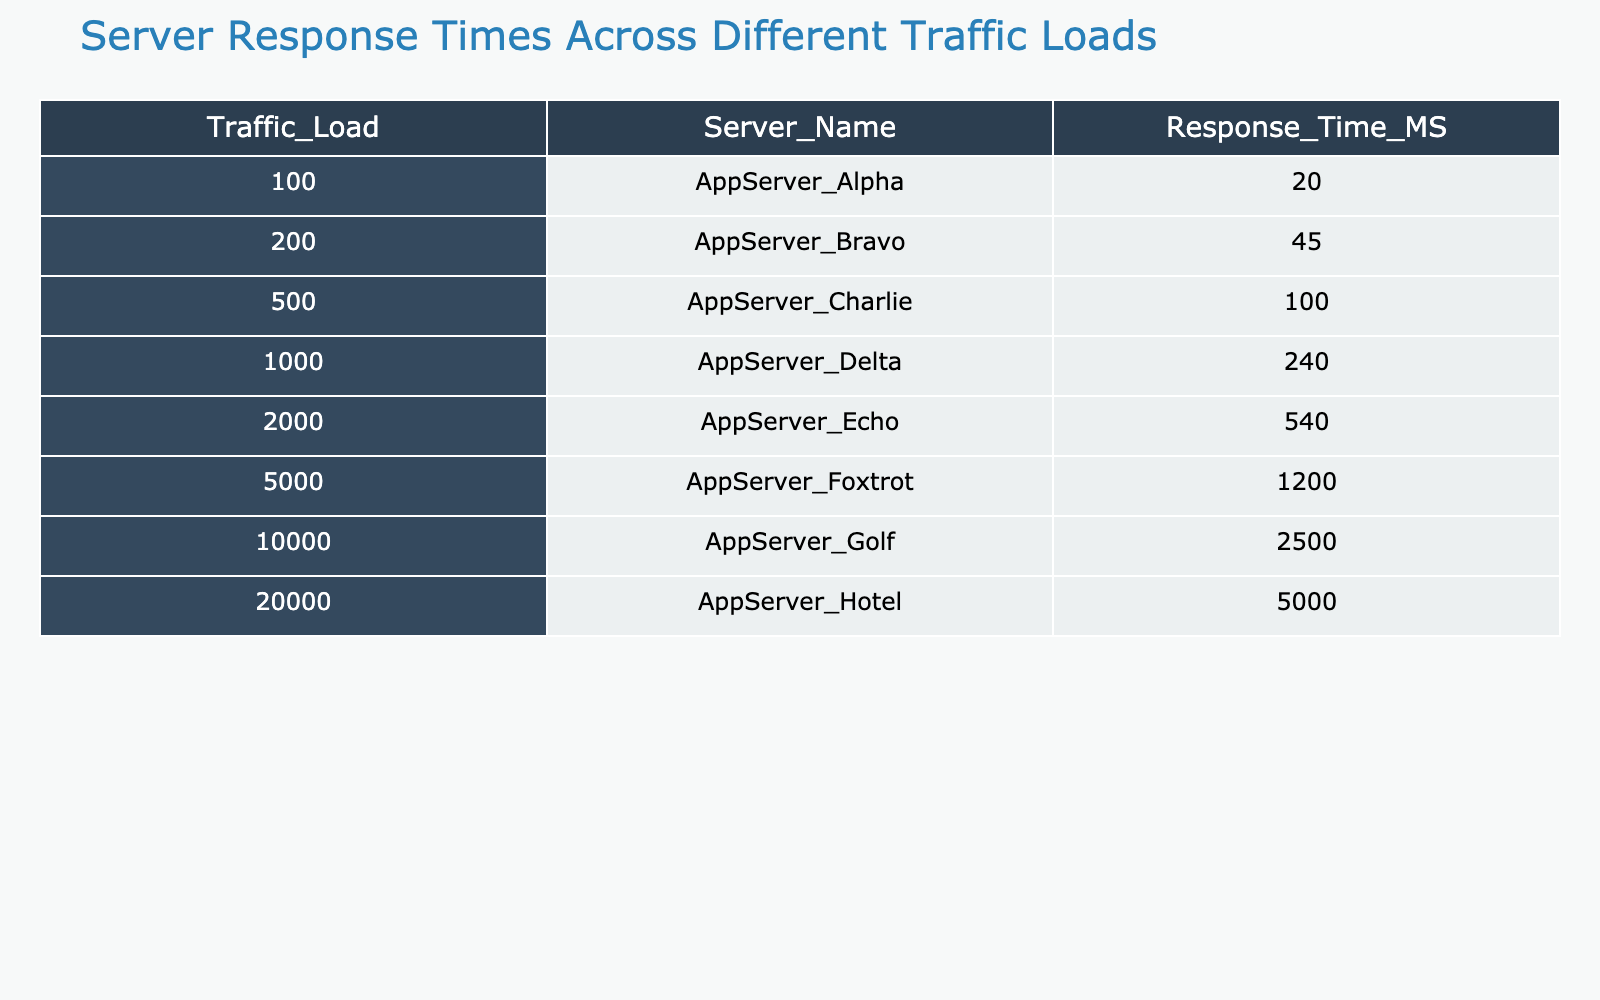What is the response time of AppServer_Delta? The table shows that for the traffic load of 1000, the response time of AppServer_Delta is 240 milliseconds.
Answer: 240 milliseconds Which server has the fastest response time? Looking at the table, AppServer_Alpha has the lowest response time of 20 milliseconds at a traffic load of 100.
Answer: AppServer_Alpha What is the average response time across all servers? To find the average, sum the response times: 20 + 45 + 100 + 240 + 540 + 1200 + 2500 + 5000 = 10245. Then divide by the number of servers (8): 10245 / 8 = 1280.625.
Answer: 1280.625 milliseconds Is the response time of AppServer_Echo less than 600 milliseconds? The response time for AppServer_Echo is 540 milliseconds, which is indeed less than 600 milliseconds.
Answer: Yes What is the difference in response time between AppServer_Foxtrot and AppServer_Golf? AppServer_Foxtrot has a response time of 1200 milliseconds, while AppServer_Golf has 2500 milliseconds. The difference is calculated as 2500 - 1200 = 1300 milliseconds.
Answer: 1300 milliseconds How many servers have a response time greater than 500 milliseconds? By examining the table, AppServer_Echo (540), AppServer_Foxtrot (1200), AppServer_Golf (2500), and AppServer_Hotel (5000) all have response times exceeding 500 milliseconds. Thus, there are 4 such servers.
Answer: 4 servers Which server experiences the highest increase in response time compared to the previous server? The response times in order are: 20 (AppServer_Alpha), 45 (AppServer_Bravo), 100 (AppServer_Charlie), 240 (AppServer_Delta), 540 (AppServer_Echo), 1200 (AppServer_Foxtrot), 2500 (AppServer_Golf), and 5000 (AppServer_Hotel). The increases are: 25, 55, 140, 300, 660, 1300, and 2500 milliseconds, respectively. The highest increase is 2500 milliseconds from AppServer_Golf to AppServer_Hotel.
Answer: 2500 milliseconds Is the response time for AppServer_Bravo greater than the average response time? The average response time, calculated previously, is 1280.625 milliseconds. The response time for AppServer_Bravo is 45 milliseconds, which is not greater than the average.
Answer: No What is the total response time when considering all servers for a traffic load of 5000 or less? Summing the response times for all servers with traffic loads of 5000 or less gives: 20 + 45 + 100 + 240 + 540 + 1200 + 2500 = 3645 milliseconds.
Answer: 3645 milliseconds 